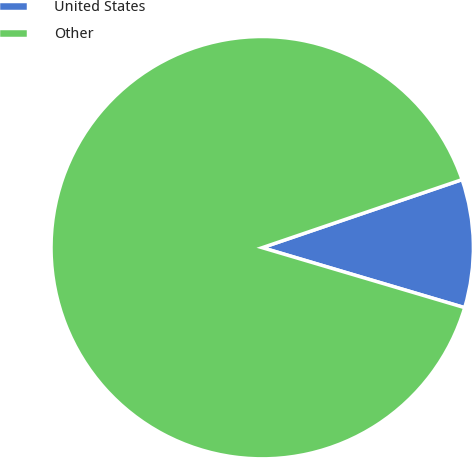Convert chart to OTSL. <chart><loc_0><loc_0><loc_500><loc_500><pie_chart><fcel>United States<fcel>Other<nl><fcel>9.81%<fcel>90.19%<nl></chart> 